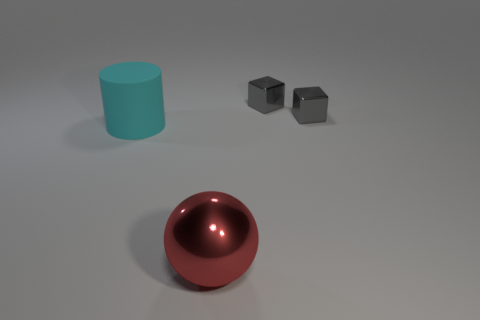Subtract all gray cubes. How many were subtracted if there are1gray cubes left? 1 Add 1 cyan things. How many objects exist? 5 Subtract all balls. How many objects are left? 3 Add 3 gray shiny objects. How many gray shiny objects are left? 5 Add 2 big matte cylinders. How many big matte cylinders exist? 3 Subtract 0 purple blocks. How many objects are left? 4 Subtract all big red shiny spheres. Subtract all cyan rubber cylinders. How many objects are left? 2 